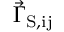Convert formula to latex. <formula><loc_0><loc_0><loc_500><loc_500>\vec { \Gamma } _ { S , i j }</formula> 